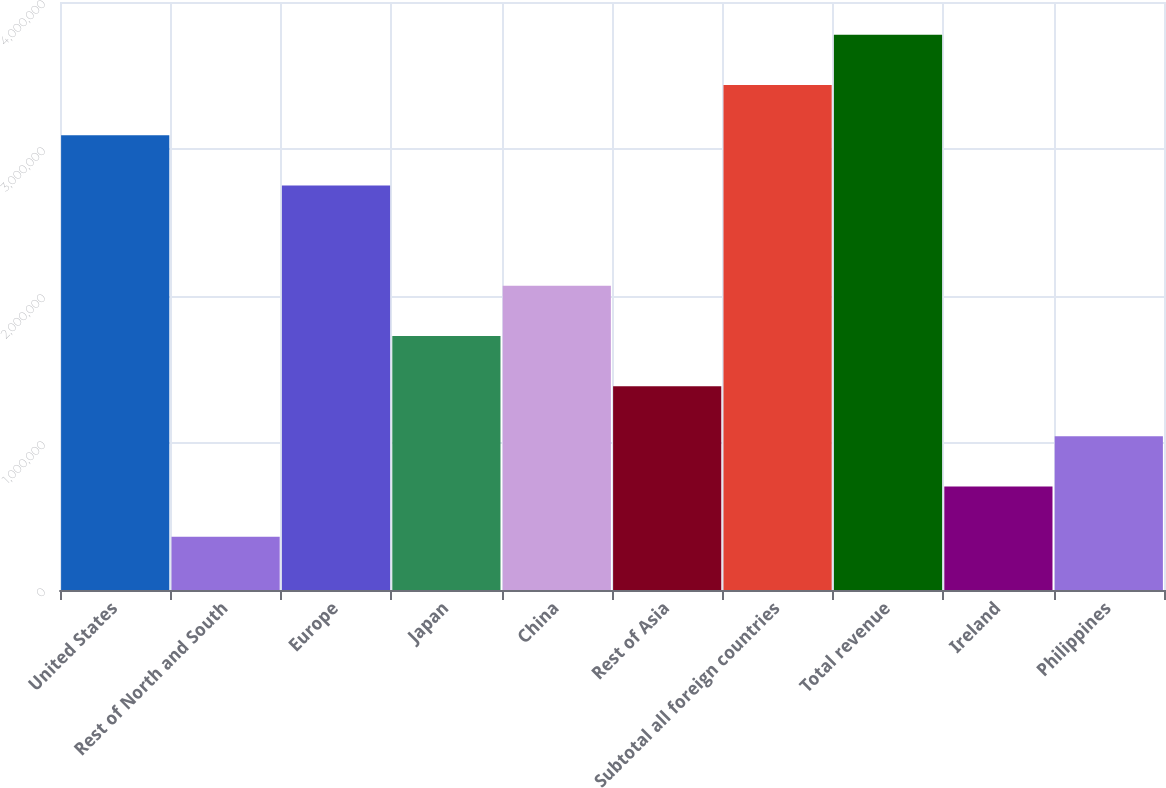Convert chart to OTSL. <chart><loc_0><loc_0><loc_500><loc_500><bar_chart><fcel>United States<fcel>Rest of North and South<fcel>Europe<fcel>Japan<fcel>China<fcel>Rest of Asia<fcel>Subtotal all foreign countries<fcel>Total revenue<fcel>Ireland<fcel>Philippines<nl><fcel>3.09372e+06<fcel>362704<fcel>2.75234e+06<fcel>1.72821e+06<fcel>2.06959e+06<fcel>1.38683e+06<fcel>3.43509e+06<fcel>3.77647e+06<fcel>704081<fcel>1.04546e+06<nl></chart> 